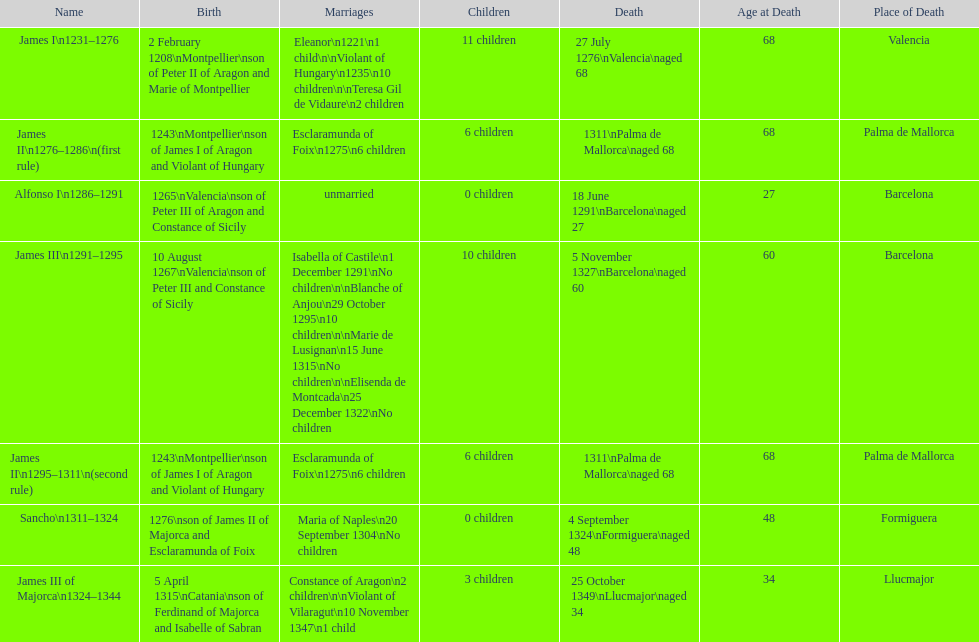Which monarch had the most marriages? James III 1291-1295. 